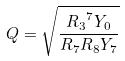Convert formula to latex. <formula><loc_0><loc_0><loc_500><loc_500>Q = \sqrt { \frac { { R _ { 3 } } ^ { 7 } Y _ { 0 } } { R _ { 7 } R _ { 8 } Y _ { 7 } } }</formula> 